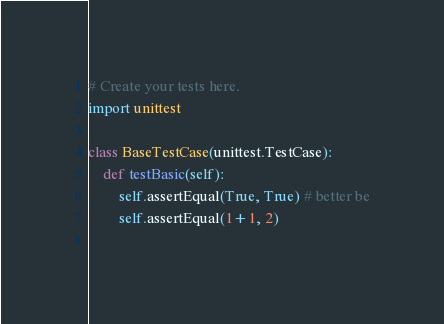Convert code to text. <code><loc_0><loc_0><loc_500><loc_500><_Python_># Create your tests here.
import unittest

class BaseTestCase(unittest.TestCase):
    def testBasic(self):
    	self.assertEqual(True, True) # better be
        self.assertEqual(1+1, 2) 
        </code> 